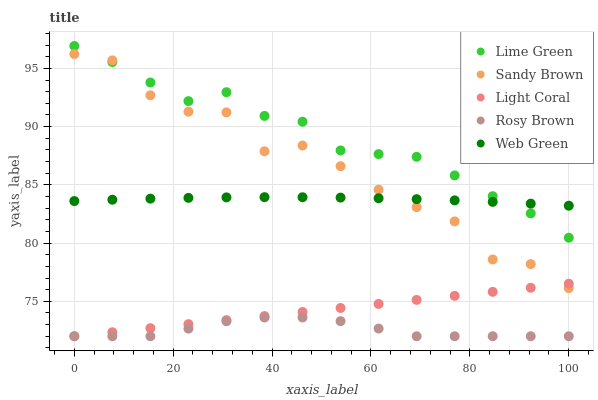Does Rosy Brown have the minimum area under the curve?
Answer yes or no. Yes. Does Lime Green have the maximum area under the curve?
Answer yes or no. Yes. Does Sandy Brown have the minimum area under the curve?
Answer yes or no. No. Does Sandy Brown have the maximum area under the curve?
Answer yes or no. No. Is Light Coral the smoothest?
Answer yes or no. Yes. Is Sandy Brown the roughest?
Answer yes or no. Yes. Is Rosy Brown the smoothest?
Answer yes or no. No. Is Rosy Brown the roughest?
Answer yes or no. No. Does Light Coral have the lowest value?
Answer yes or no. Yes. Does Sandy Brown have the lowest value?
Answer yes or no. No. Does Lime Green have the highest value?
Answer yes or no. Yes. Does Sandy Brown have the highest value?
Answer yes or no. No. Is Rosy Brown less than Lime Green?
Answer yes or no. Yes. Is Lime Green greater than Rosy Brown?
Answer yes or no. Yes. Does Lime Green intersect Sandy Brown?
Answer yes or no. Yes. Is Lime Green less than Sandy Brown?
Answer yes or no. No. Is Lime Green greater than Sandy Brown?
Answer yes or no. No. Does Rosy Brown intersect Lime Green?
Answer yes or no. No. 